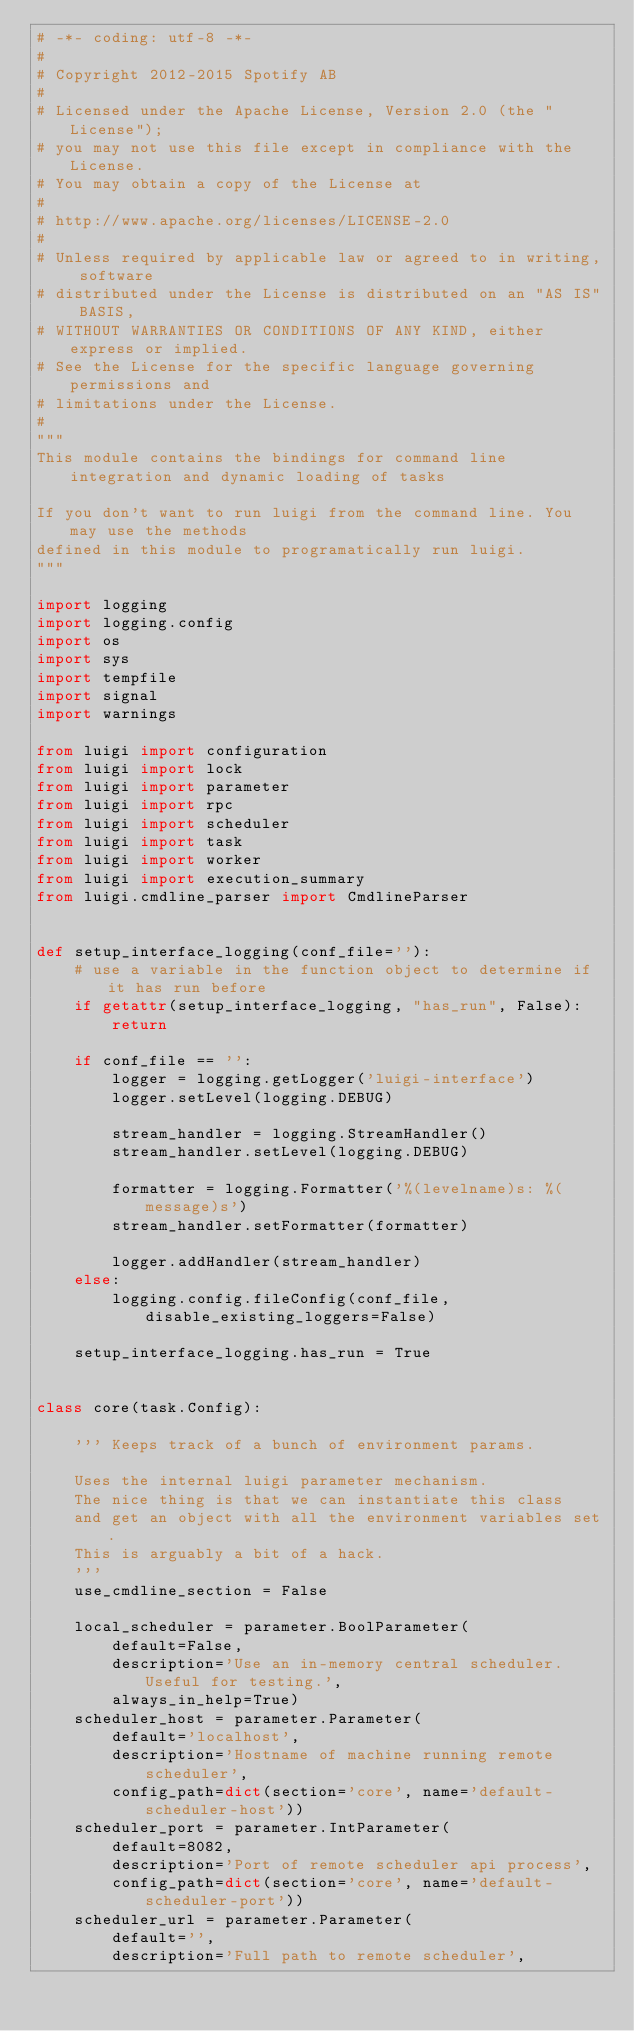<code> <loc_0><loc_0><loc_500><loc_500><_Python_># -*- coding: utf-8 -*-
#
# Copyright 2012-2015 Spotify AB
#
# Licensed under the Apache License, Version 2.0 (the "License");
# you may not use this file except in compliance with the License.
# You may obtain a copy of the License at
#
# http://www.apache.org/licenses/LICENSE-2.0
#
# Unless required by applicable law or agreed to in writing, software
# distributed under the License is distributed on an "AS IS" BASIS,
# WITHOUT WARRANTIES OR CONDITIONS OF ANY KIND, either express or implied.
# See the License for the specific language governing permissions and
# limitations under the License.
#
"""
This module contains the bindings for command line integration and dynamic loading of tasks

If you don't want to run luigi from the command line. You may use the methods
defined in this module to programatically run luigi.
"""

import logging
import logging.config
import os
import sys
import tempfile
import signal
import warnings

from luigi import configuration
from luigi import lock
from luigi import parameter
from luigi import rpc
from luigi import scheduler
from luigi import task
from luigi import worker
from luigi import execution_summary
from luigi.cmdline_parser import CmdlineParser


def setup_interface_logging(conf_file=''):
    # use a variable in the function object to determine if it has run before
    if getattr(setup_interface_logging, "has_run", False):
        return

    if conf_file == '':
        logger = logging.getLogger('luigi-interface')
        logger.setLevel(logging.DEBUG)

        stream_handler = logging.StreamHandler()
        stream_handler.setLevel(logging.DEBUG)

        formatter = logging.Formatter('%(levelname)s: %(message)s')
        stream_handler.setFormatter(formatter)

        logger.addHandler(stream_handler)
    else:
        logging.config.fileConfig(conf_file, disable_existing_loggers=False)

    setup_interface_logging.has_run = True


class core(task.Config):

    ''' Keeps track of a bunch of environment params.

    Uses the internal luigi parameter mechanism.
    The nice thing is that we can instantiate this class
    and get an object with all the environment variables set.
    This is arguably a bit of a hack.
    '''
    use_cmdline_section = False

    local_scheduler = parameter.BoolParameter(
        default=False,
        description='Use an in-memory central scheduler. Useful for testing.',
        always_in_help=True)
    scheduler_host = parameter.Parameter(
        default='localhost',
        description='Hostname of machine running remote scheduler',
        config_path=dict(section='core', name='default-scheduler-host'))
    scheduler_port = parameter.IntParameter(
        default=8082,
        description='Port of remote scheduler api process',
        config_path=dict(section='core', name='default-scheduler-port'))
    scheduler_url = parameter.Parameter(
        default='',
        description='Full path to remote scheduler',</code> 